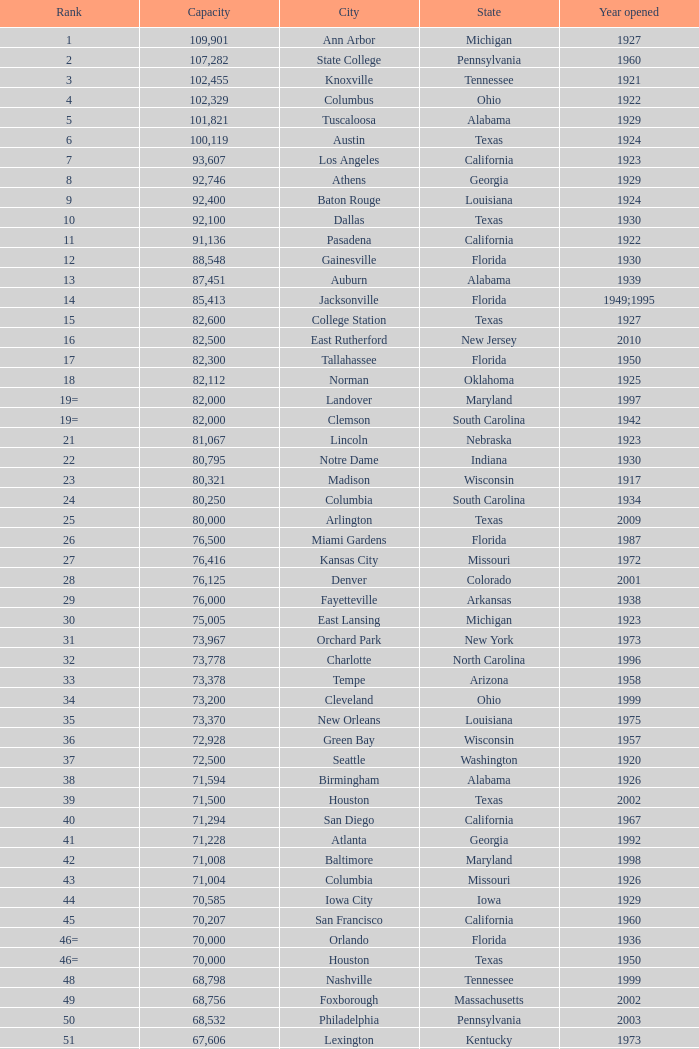What is the lowest capacity for 1903? 30323.0. 